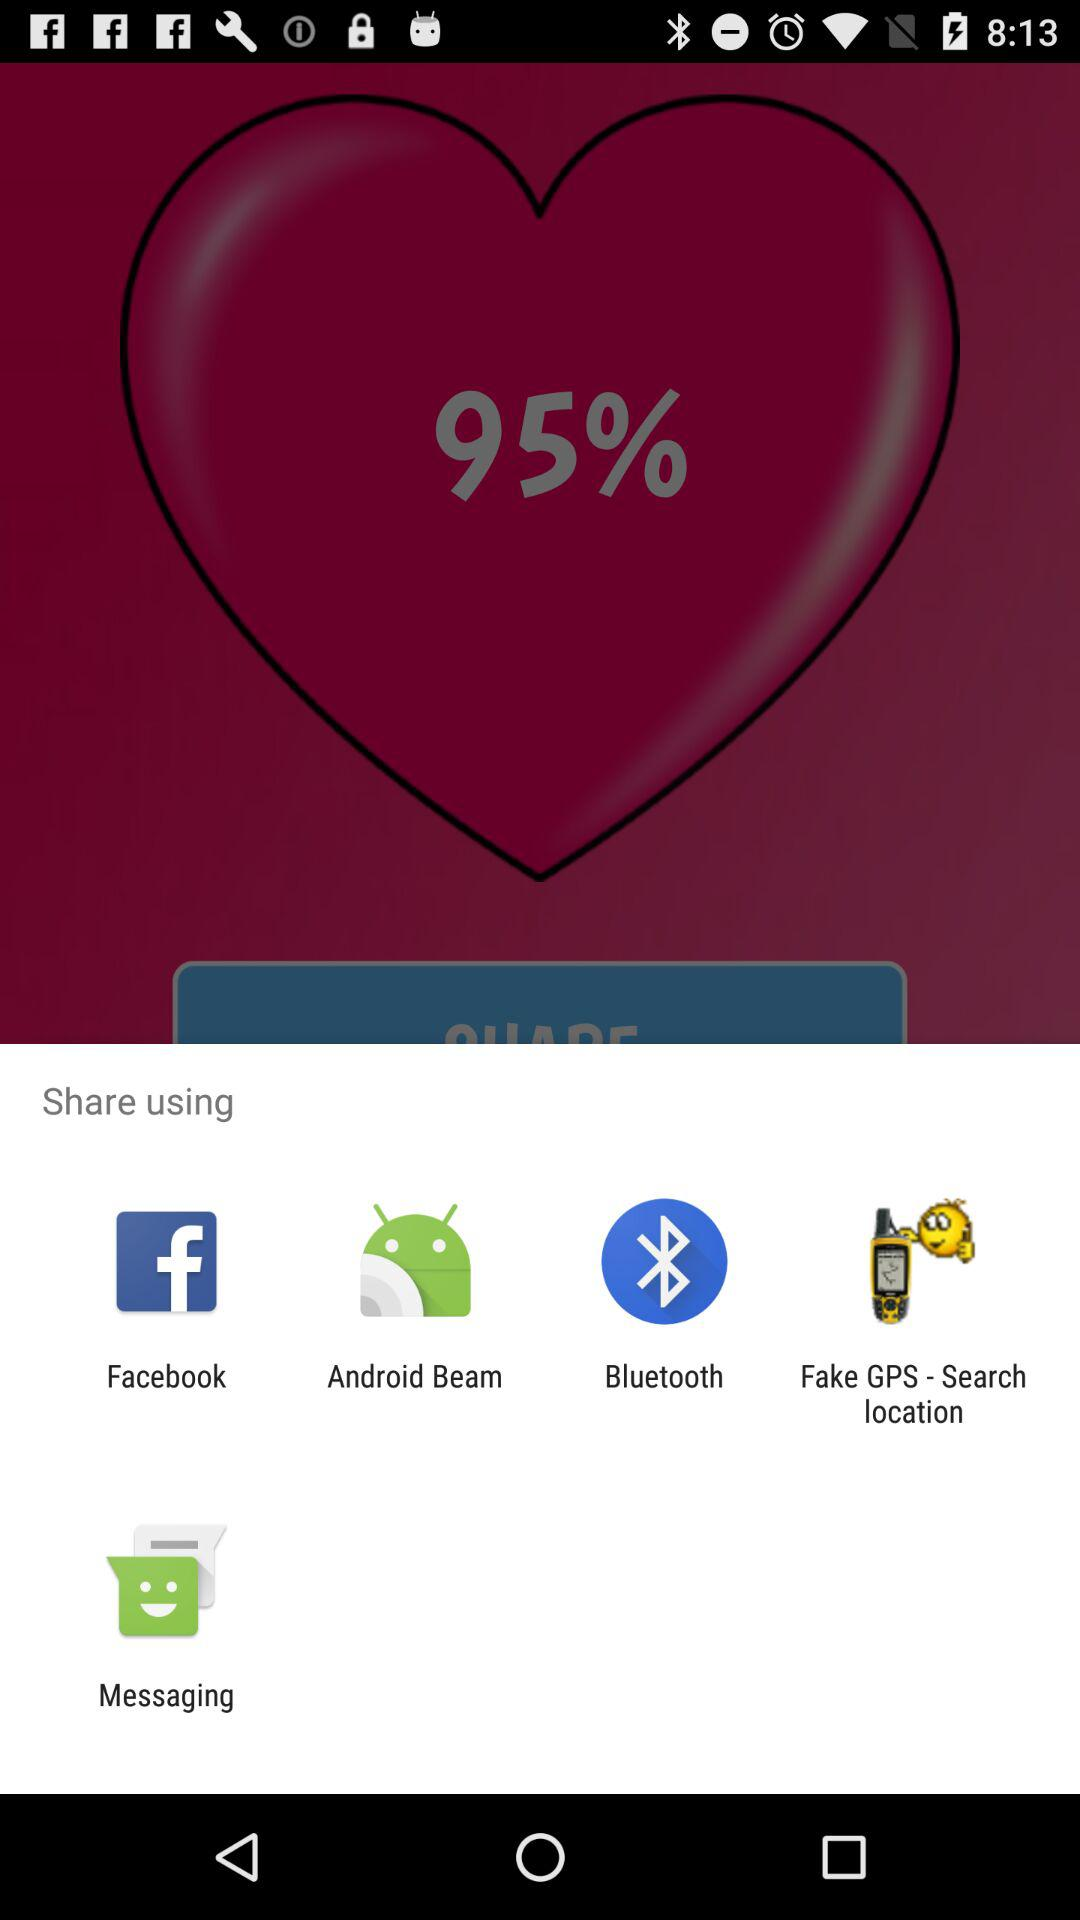Through what apps can we share? You can share with "Facebook", "Android Beam", "Bluetooth", "Fake GPS - Search location" and "Messaging". 